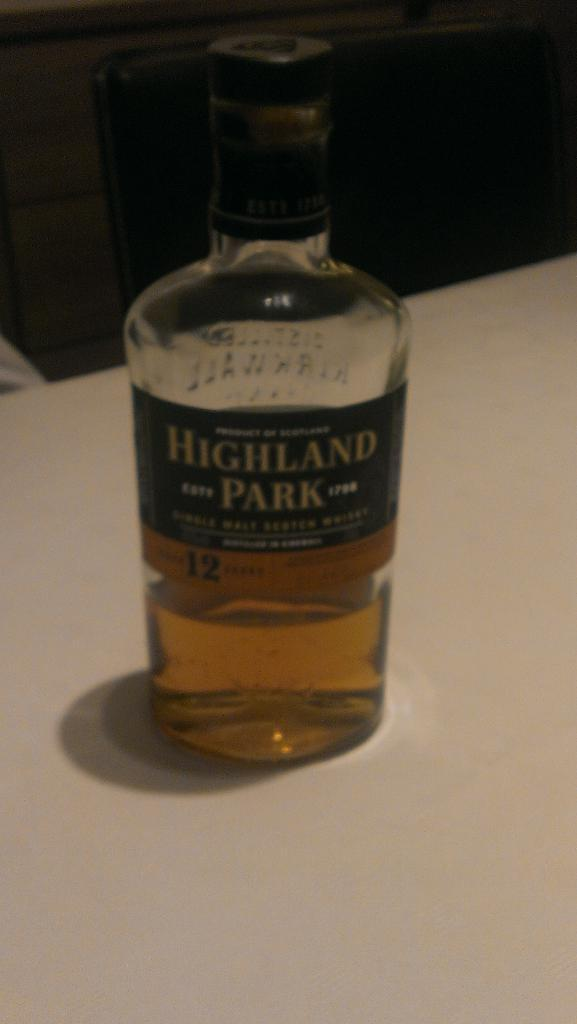<image>
Give a short and clear explanation of the subsequent image. A clear bottle with a label that says Highland Park. 